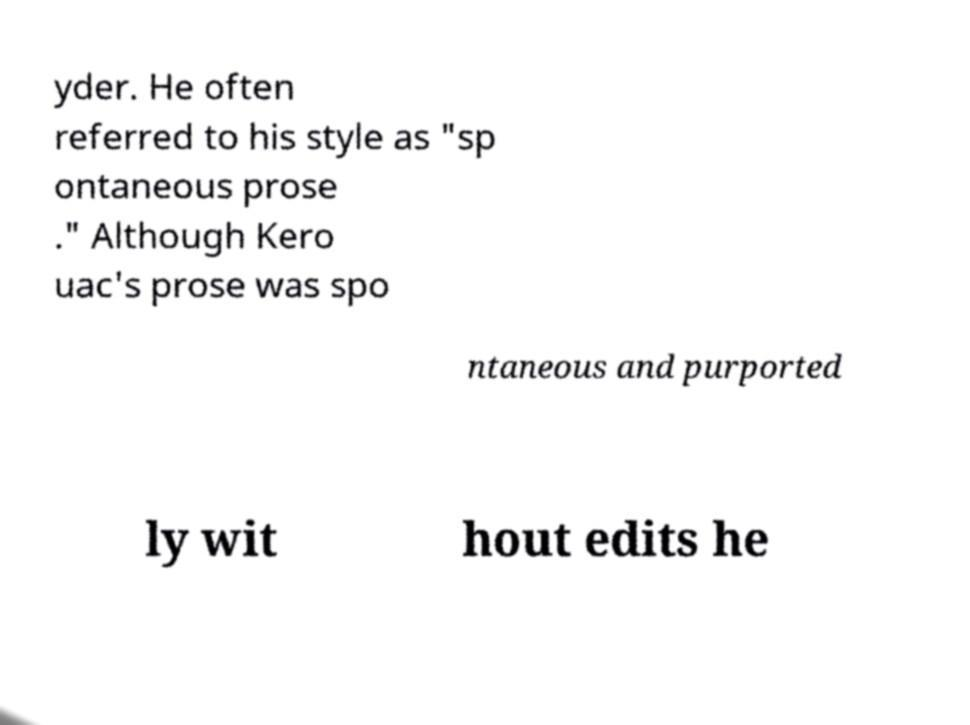Can you accurately transcribe the text from the provided image for me? yder. He often referred to his style as "sp ontaneous prose ." Although Kero uac's prose was spo ntaneous and purported ly wit hout edits he 